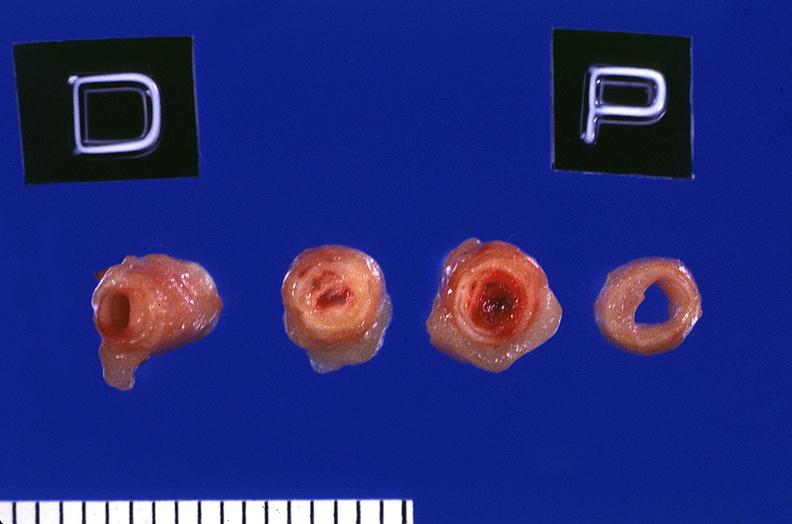does this image show coronary artery with atherosclerosis and thrombotic occlusion?
Answer the question using a single word or phrase. Yes 